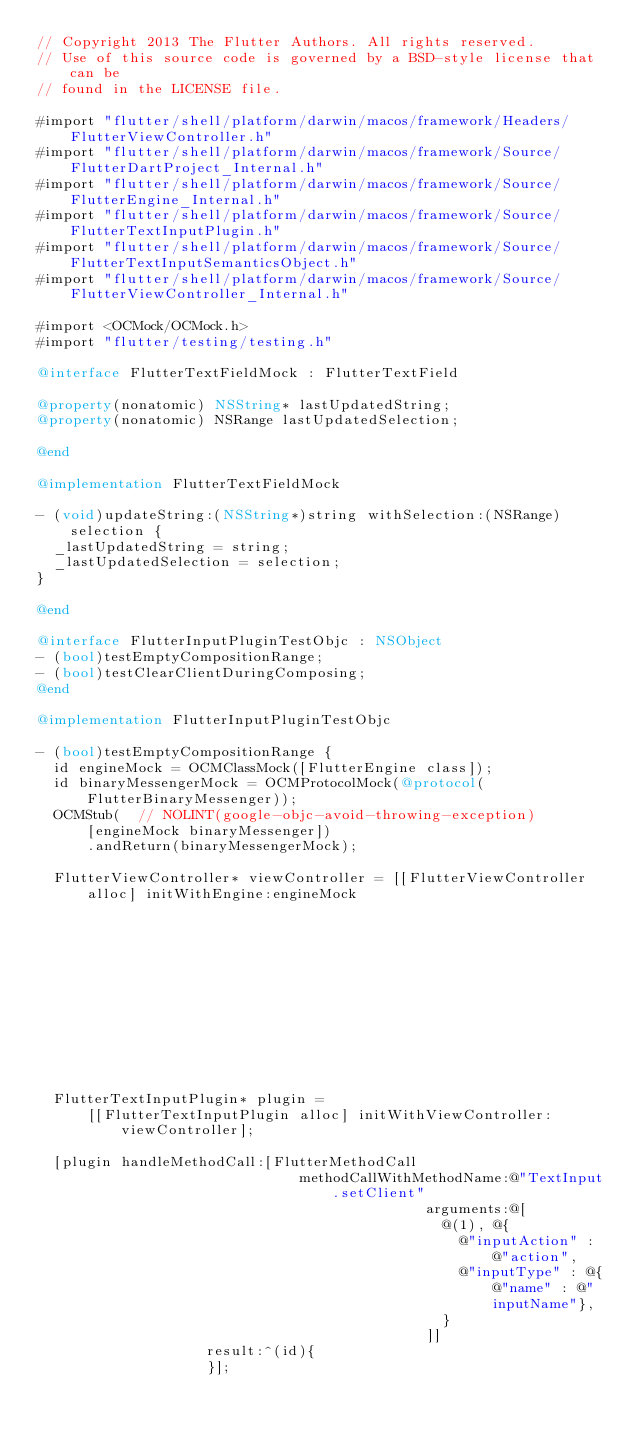<code> <loc_0><loc_0><loc_500><loc_500><_ObjectiveC_>// Copyright 2013 The Flutter Authors. All rights reserved.
// Use of this source code is governed by a BSD-style license that can be
// found in the LICENSE file.

#import "flutter/shell/platform/darwin/macos/framework/Headers/FlutterViewController.h"
#import "flutter/shell/platform/darwin/macos/framework/Source/FlutterDartProject_Internal.h"
#import "flutter/shell/platform/darwin/macos/framework/Source/FlutterEngine_Internal.h"
#import "flutter/shell/platform/darwin/macos/framework/Source/FlutterTextInputPlugin.h"
#import "flutter/shell/platform/darwin/macos/framework/Source/FlutterTextInputSemanticsObject.h"
#import "flutter/shell/platform/darwin/macos/framework/Source/FlutterViewController_Internal.h"

#import <OCMock/OCMock.h>
#import "flutter/testing/testing.h"

@interface FlutterTextFieldMock : FlutterTextField

@property(nonatomic) NSString* lastUpdatedString;
@property(nonatomic) NSRange lastUpdatedSelection;

@end

@implementation FlutterTextFieldMock

- (void)updateString:(NSString*)string withSelection:(NSRange)selection {
  _lastUpdatedString = string;
  _lastUpdatedSelection = selection;
}

@end

@interface FlutterInputPluginTestObjc : NSObject
- (bool)testEmptyCompositionRange;
- (bool)testClearClientDuringComposing;
@end

@implementation FlutterInputPluginTestObjc

- (bool)testEmptyCompositionRange {
  id engineMock = OCMClassMock([FlutterEngine class]);
  id binaryMessengerMock = OCMProtocolMock(@protocol(FlutterBinaryMessenger));
  OCMStub(  // NOLINT(google-objc-avoid-throwing-exception)
      [engineMock binaryMessenger])
      .andReturn(binaryMessengerMock);

  FlutterViewController* viewController = [[FlutterViewController alloc] initWithEngine:engineMock
                                                                                nibName:@""
                                                                                 bundle:nil];

  FlutterTextInputPlugin* plugin =
      [[FlutterTextInputPlugin alloc] initWithViewController:viewController];

  [plugin handleMethodCall:[FlutterMethodCall
                               methodCallWithMethodName:@"TextInput.setClient"
                                              arguments:@[
                                                @(1), @{
                                                  @"inputAction" : @"action",
                                                  @"inputType" : @{@"name" : @"inputName"},
                                                }
                                              ]]
                    result:^(id){
                    }];
</code> 